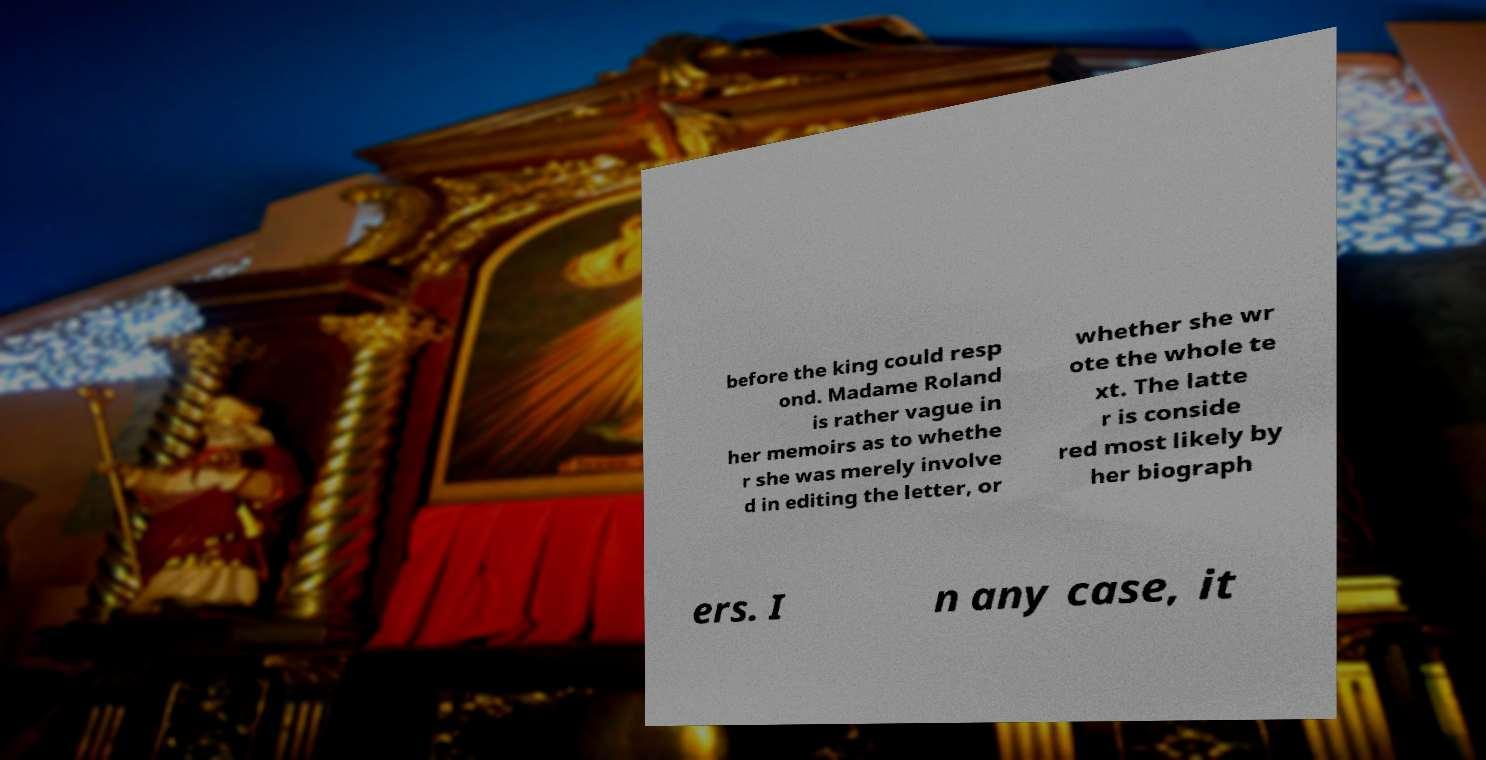There's text embedded in this image that I need extracted. Can you transcribe it verbatim? before the king could resp ond. Madame Roland is rather vague in her memoirs as to whethe r she was merely involve d in editing the letter, or whether she wr ote the whole te xt. The latte r is conside red most likely by her biograph ers. I n any case, it 